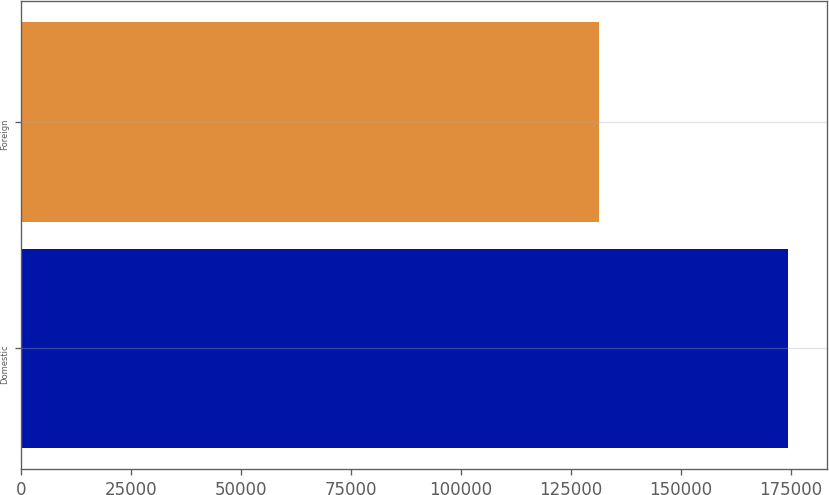Convert chart. <chart><loc_0><loc_0><loc_500><loc_500><bar_chart><fcel>Domestic<fcel>Foreign<nl><fcel>174412<fcel>131458<nl></chart> 